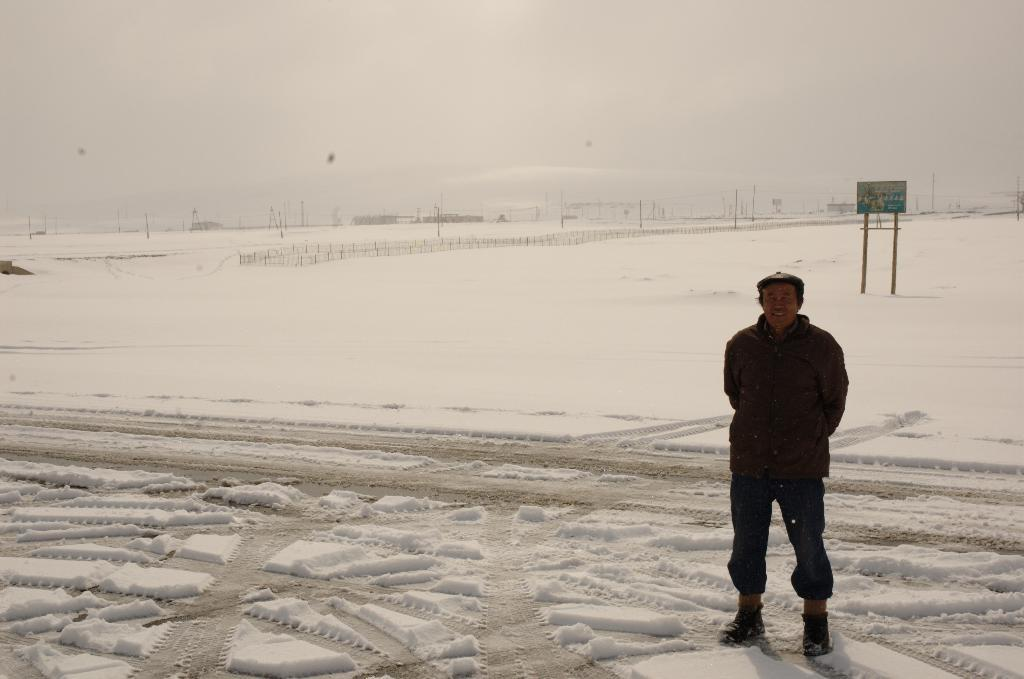What is the condition of the land in the image? The land is covered with snow. Can you describe the person in the image? There is a man in the image. What can be seen in the distance in the image? There is a fence and a board in the distance. How does the baby interact with the pump in the image? There is no baby or pump present in the image. 